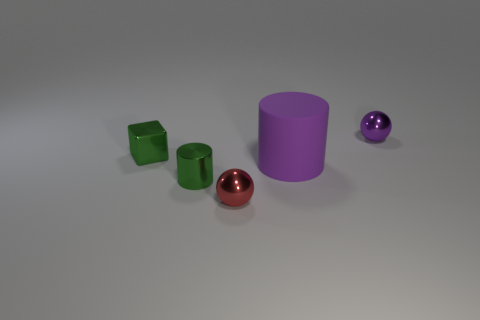Are there any other things that have the same material as the large cylinder?
Make the answer very short. No. Are there an equal number of purple rubber cylinders that are behind the tiny green block and balls?
Ensure brevity in your answer.  No. The purple object that is the same size as the cube is what shape?
Offer a very short reply. Sphere. There is a tiny shiny object to the left of the small shiny cylinder; is there a shiny object that is to the left of it?
Provide a succinct answer. No. What number of small objects are either rubber cylinders or red cylinders?
Provide a succinct answer. 0. Is there a cylinder of the same size as the block?
Keep it short and to the point. Yes. How many metal objects are purple cylinders or blue objects?
Offer a very short reply. 0. The small metal thing that is the same color as the large thing is what shape?
Provide a short and direct response. Sphere. How many big red metallic objects are there?
Provide a succinct answer. 0. Is the purple object to the right of the large rubber cylinder made of the same material as the cylinder that is on the left side of the small red ball?
Make the answer very short. Yes. 